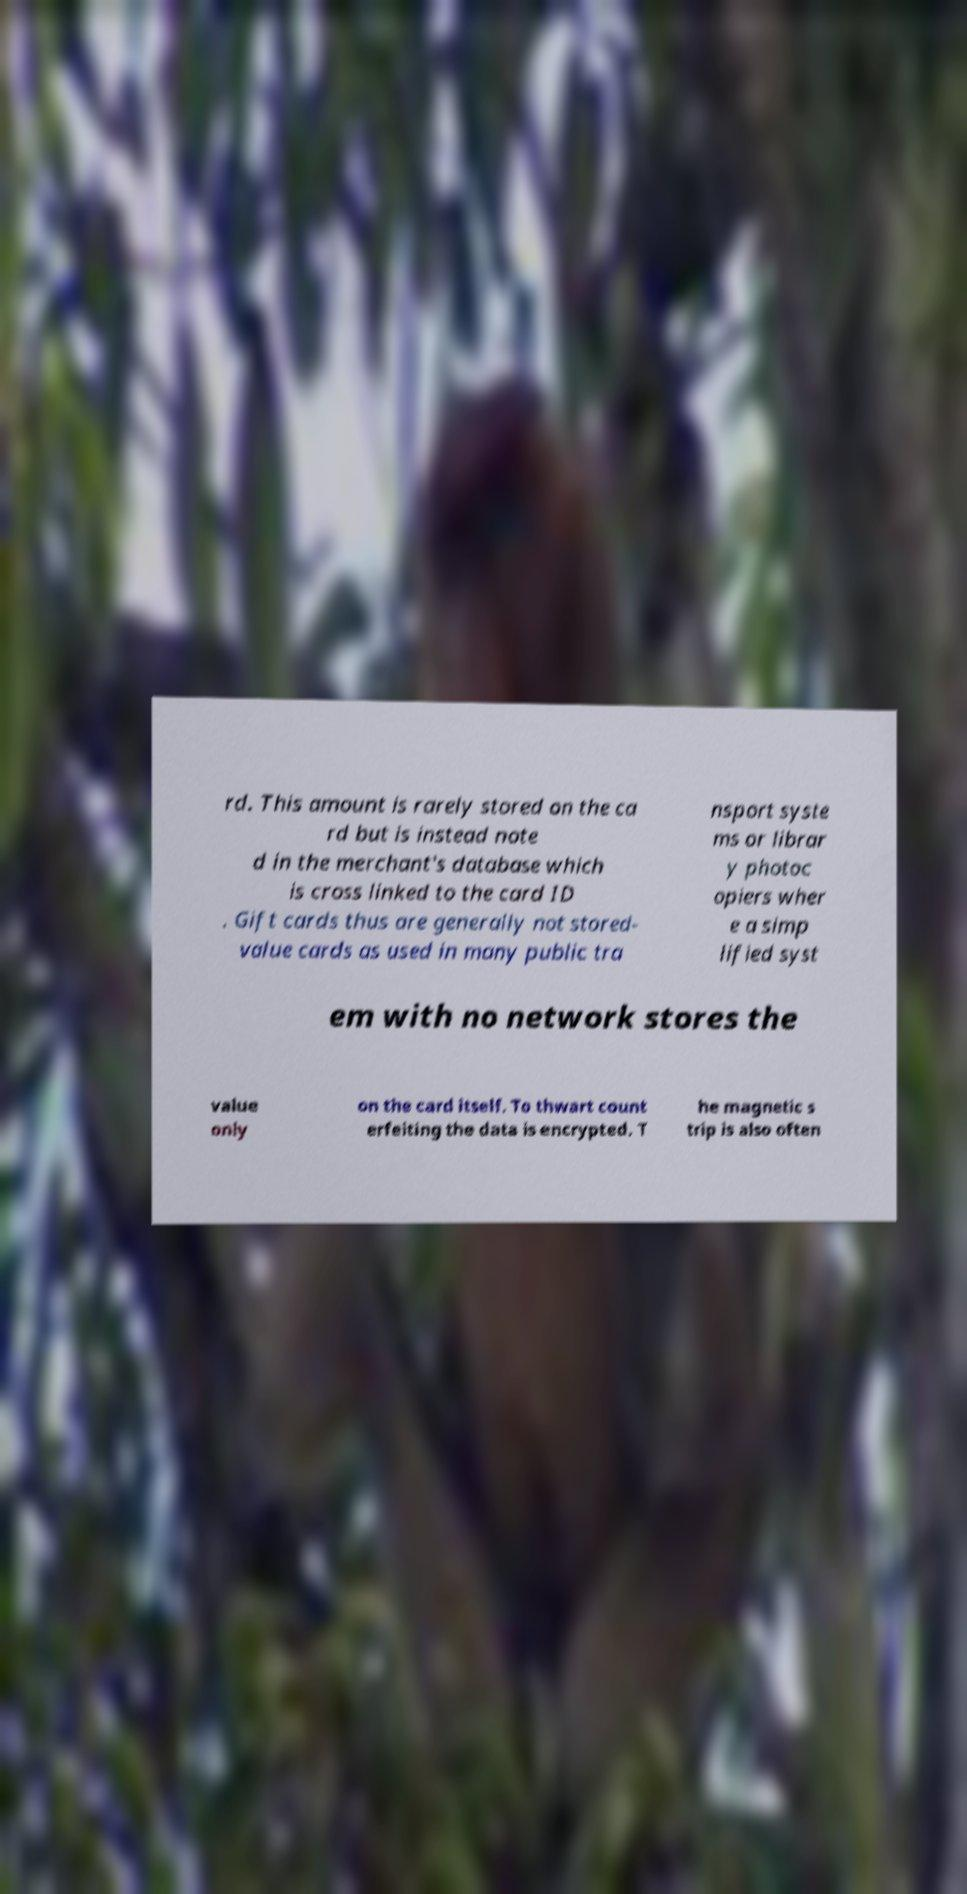There's text embedded in this image that I need extracted. Can you transcribe it verbatim? rd. This amount is rarely stored on the ca rd but is instead note d in the merchant's database which is cross linked to the card ID . Gift cards thus are generally not stored- value cards as used in many public tra nsport syste ms or librar y photoc opiers wher e a simp lified syst em with no network stores the value only on the card itself. To thwart count erfeiting the data is encrypted. T he magnetic s trip is also often 